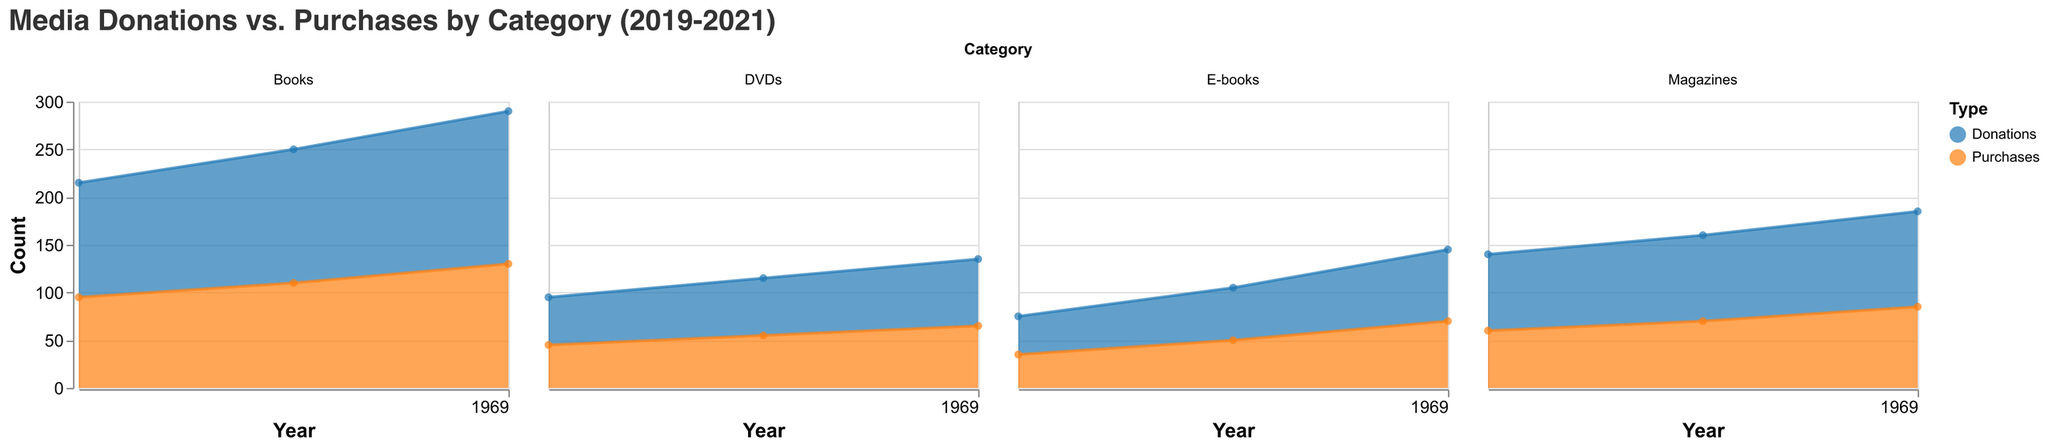What does the title of the chart indicate? The title states "Media Donations vs. Purchases by Category (2019-2021)," which means the chart compares the number of donations versus purchases across different media categories (like Books, Magazines, DVDs, and E-books) annually from 2019 to 2021.
Answer: Media Donations vs. Purchases by Category (2019-2021) What year saw the highest number of donations for DVDs? In the subplot for DVDs, the highest point in the Donations area occurs in the year 2021, with 70 donations.
Answer: 2021 How did the number of purchases for Books change from 2019 to 2020? Based on the Book subplot, in 2019, there were 95 purchases and in 2020, there were 110 purchases. Therefore, purchases increased by 15 units from 2019 to 2020.
Answer: Increased by 15 Which category had more purchases than donations in 2021? Only by looking at the area charts, we see that, for each category, the Purchases line is consistently below the Donations line. Therefore, there are no categories where purchases exceeded donations in 2021.
Answer: None What is the total number of donations for E-books across all years? Sum the donations for E-books over the three years: 2019 (40) + 2020 (55) + 2021 (75) = 170 donations in total.
Answer: 170 In which year did the number of donations for Magazines surpass 90? By looking at the subplot for Magazines, donations surpass 90 in the years 2020 (90) and 2021 (100). However, they only exceed 90 in 2021.
Answer: 2021 Compare the trends in donations for Books and E-books from 2019 to 2021. Observe that both Books and E-books show an increasing trend in donations from 2019 to 2021, where Books are from 120 to 160 and E-books are from 40 to 75, respectively. Hence, both categories have upward trends with growing slopes.
Answer: Increasing trend What's the average number of purchases for Magazines from 2019 to 2021? To find the average: (60 in 2019 + 70 in 2020 + 85 in 2021) / 3 = 215 / 3 = approximately 71.67.
Answer: Approximately 71.67 